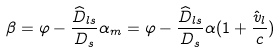Convert formula to latex. <formula><loc_0><loc_0><loc_500><loc_500>\beta = \varphi - \frac { \widehat { D } _ { l s } } { D _ { s } } \alpha _ { m } = \varphi - \frac { \widehat { D } _ { l s } } { D _ { s } } \alpha ( 1 + \frac { \hat { v } _ { l } } { c } )</formula> 